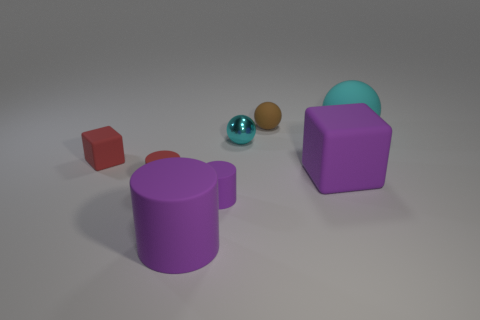Add 2 small purple things. How many objects exist? 10 Subtract all cubes. How many objects are left? 6 Subtract 0 cyan blocks. How many objects are left? 8 Subtract all tiny cyan shiny things. Subtract all small red rubber cylinders. How many objects are left? 6 Add 1 large cylinders. How many large cylinders are left? 2 Add 1 big cylinders. How many big cylinders exist? 2 